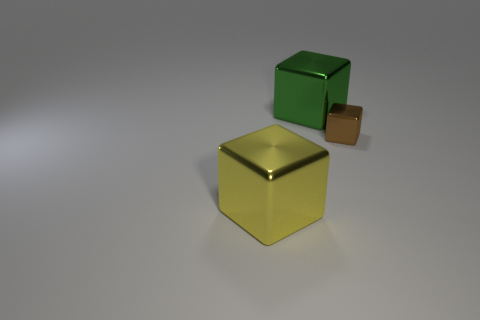Subtract all tiny brown metal cubes. How many cubes are left? 2 Add 1 brown cubes. How many objects exist? 4 Subtract 2 blocks. How many blocks are left? 1 Subtract all green blocks. How many blocks are left? 2 Subtract all cyan spheres. How many brown blocks are left? 1 Subtract all purple rubber spheres. Subtract all large yellow metallic objects. How many objects are left? 2 Add 3 large yellow blocks. How many large yellow blocks are left? 4 Add 2 shiny cubes. How many shiny cubes exist? 5 Subtract 0 red balls. How many objects are left? 3 Subtract all gray cubes. Subtract all green cylinders. How many cubes are left? 3 